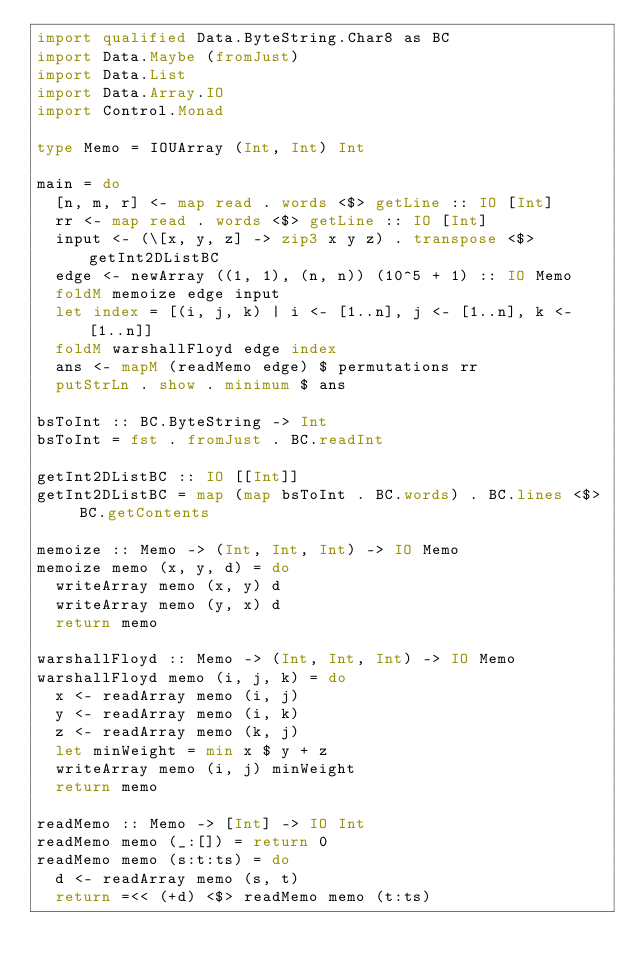<code> <loc_0><loc_0><loc_500><loc_500><_Haskell_>import qualified Data.ByteString.Char8 as BC
import Data.Maybe (fromJust)
import Data.List
import Data.Array.IO
import Control.Monad

type Memo = IOUArray (Int, Int) Int

main = do
  [n, m, r] <- map read . words <$> getLine :: IO [Int]
  rr <- map read . words <$> getLine :: IO [Int]
  input <- (\[x, y, z] -> zip3 x y z) . transpose <$> getInt2DListBC
  edge <- newArray ((1, 1), (n, n)) (10^5 + 1) :: IO Memo
  foldM memoize edge input
  let index = [(i, j, k) | i <- [1..n], j <- [1..n], k <- [1..n]]
  foldM warshallFloyd edge index
  ans <- mapM (readMemo edge) $ permutations rr
  putStrLn . show . minimum $ ans

bsToInt :: BC.ByteString -> Int
bsToInt = fst . fromJust . BC.readInt

getInt2DListBC :: IO [[Int]]
getInt2DListBC = map (map bsToInt . BC.words) . BC.lines <$> BC.getContents

memoize :: Memo -> (Int, Int, Int) -> IO Memo
memoize memo (x, y, d) = do
  writeArray memo (x, y) d
  writeArray memo (y, x) d
  return memo

warshallFloyd :: Memo -> (Int, Int, Int) -> IO Memo
warshallFloyd memo (i, j, k) = do
  x <- readArray memo (i, j)
  y <- readArray memo (i, k)
  z <- readArray memo (k, j)
  let minWeight = min x $ y + z
  writeArray memo (i, j) minWeight
  return memo

readMemo :: Memo -> [Int] -> IO Int
readMemo memo (_:[]) = return 0
readMemo memo (s:t:ts) = do
  d <- readArray memo (s, t)
  return =<< (+d) <$> readMemo memo (t:ts)
</code> 